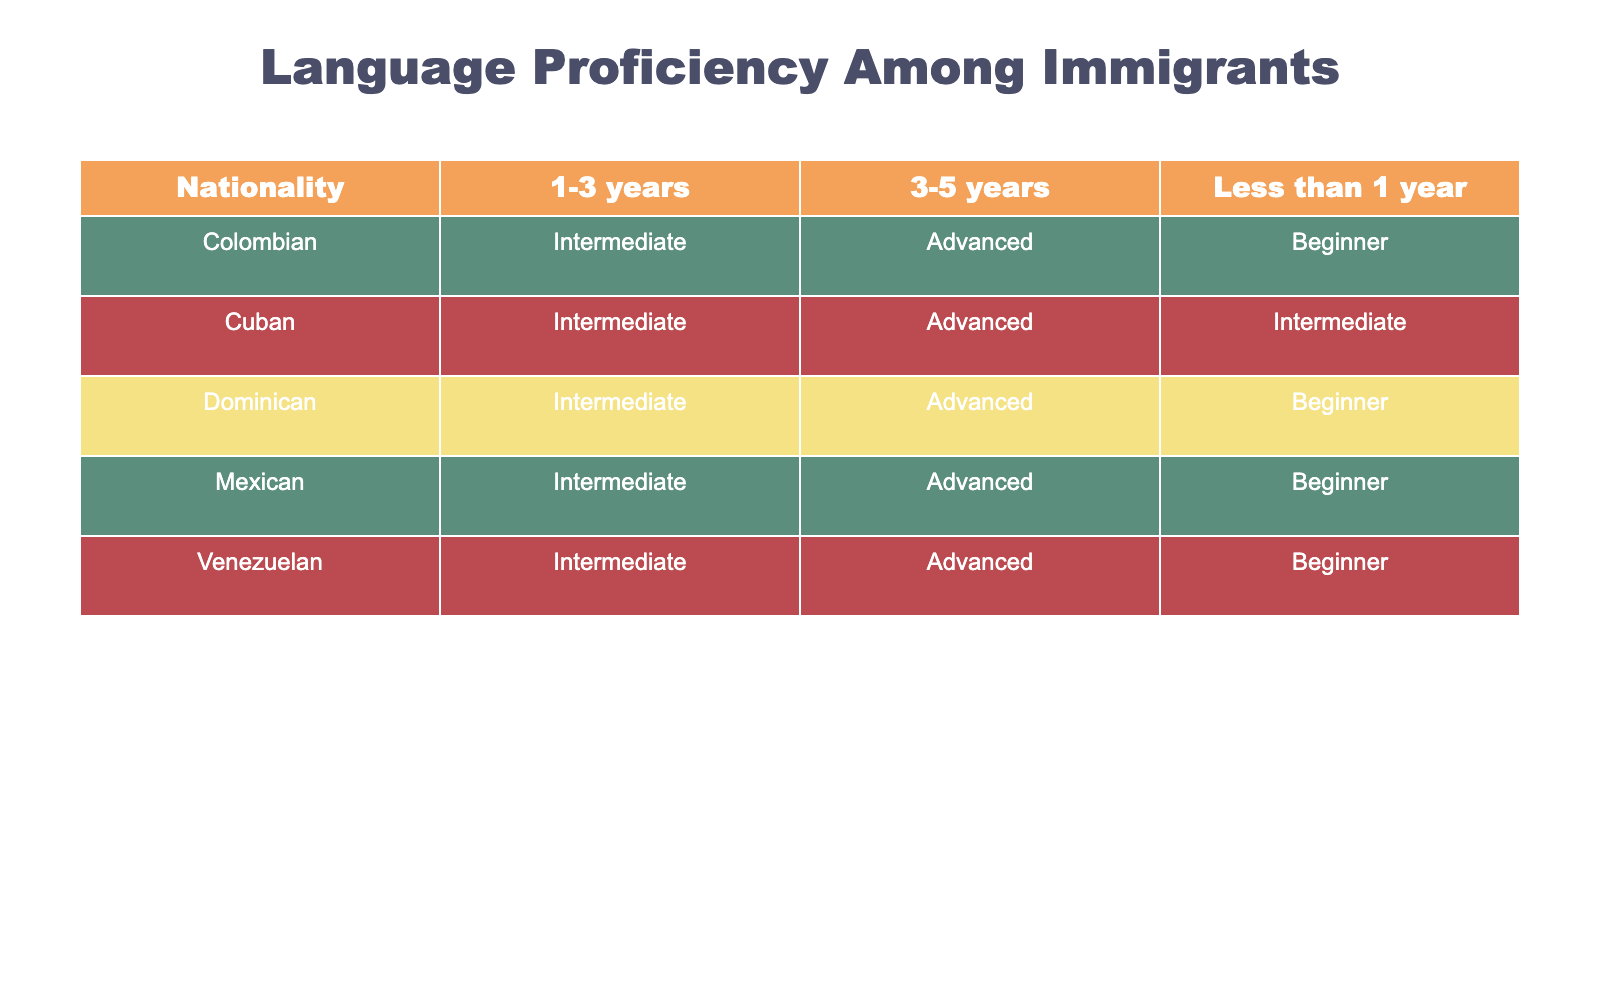What language proficiency do most Colombians have after staying for 1-3 years? There are three entries for Colombians with a duration of stay of 1-3 years. The language proficiency for all of them is 'Intermediate'. Therefore, most Colombians after this duration have an 'Intermediate' proficiency level.
Answer: Intermediate How many total nationalities are represented in the table? The table shows data for five distinct nationalities: Colombian, Mexican, Cuban, Dominican, and Venezuelan. Counting these gives us a total of five nationalities.
Answer: 5 Is there any nationality that has a majority of beginners after less than one year? According to the table, both Colombians and Mexicans are categorized as 'Beginner' after less than one year. However, there is no single nationality that has a majority, as both have the same proficiency level within that duration. Therefore, the answer is 'No'.
Answer: No What is the difference in language proficiency levels between Cubans who have been in the country for less than one year and those who have been here for 3-5 years? For Cubans, the proficiency level is 'Intermediate' for less than one year and 'Advanced' for 3-5 years. The difference in language levels suggests an improvement from 'Intermediate' to 'Advanced' over time. As levels progress from Beginner, Intermediate, to Advanced, the change reflects growth in language skills.
Answer: Intermediate to Advanced Which nationality has the highest progression in language proficiency over time based on the table? To analyze progression, we examine the proficiency levels for each nationality. Colombians and Dominicans start with 'Beginner' and move to 'Intermediate' and then to 'Advanced'. However, only Dominicans achieve 'Advanced' after 3-5 years, while Colombians also reach 'Advanced', but not all categories are filled with 'Intermediate' consistently. Therefore, both Colombian and Dominican nationalities have high progression, but Dominicans have a clearer and consistent progression.
Answer: Dominicans Do Venezuelans show improvement in language proficiency after staying for more than three years? The table indicates that Venezuelans start at 'Beginner', progress to 'Intermediate' after 1-3 years, and then advance to 'Advanced' after 3-5 years. This reveals a clear improvement in their language proficiency as the duration of stay increases.
Answer: Yes 